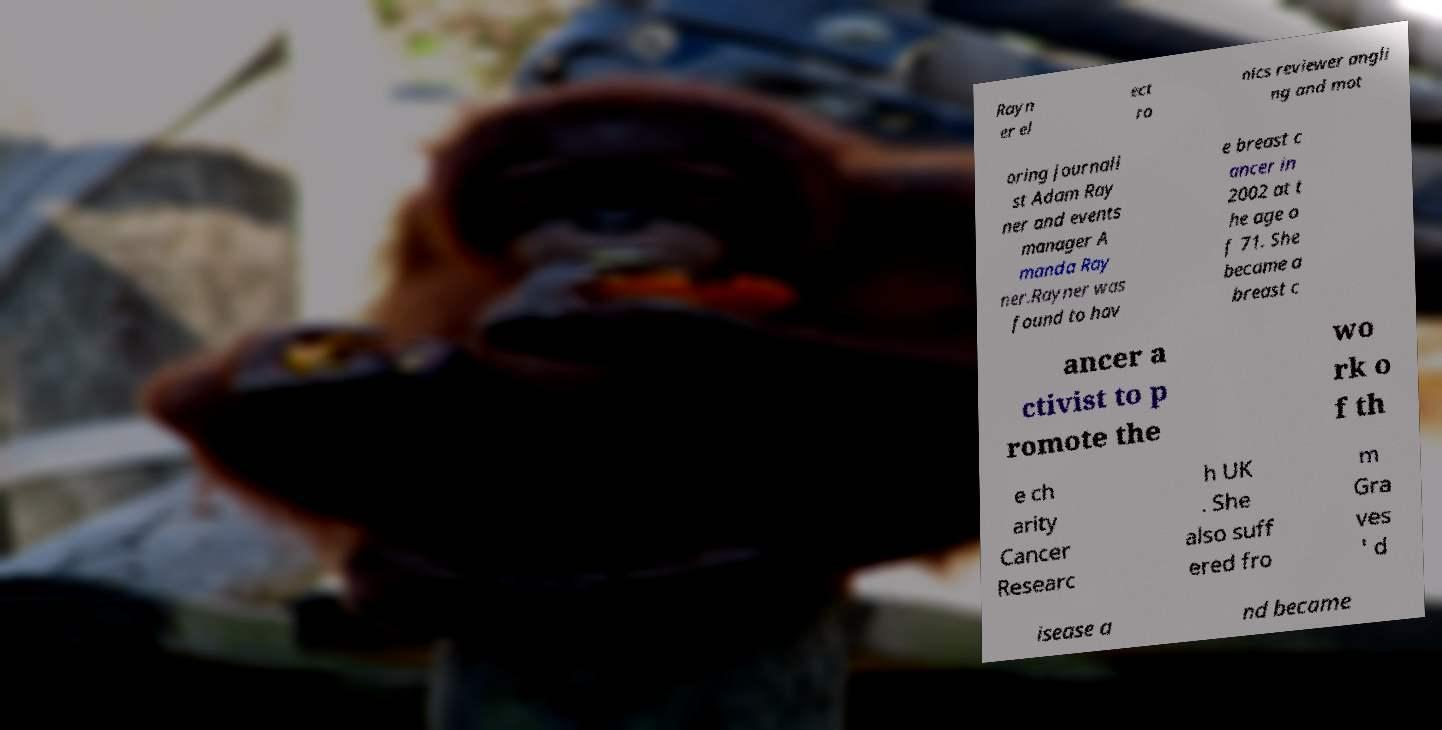Can you accurately transcribe the text from the provided image for me? Rayn er el ect ro nics reviewer angli ng and mot oring journali st Adam Ray ner and events manager A manda Ray ner.Rayner was found to hav e breast c ancer in 2002 at t he age o f 71. She became a breast c ancer a ctivist to p romote the wo rk o f th e ch arity Cancer Researc h UK . She also suff ered fro m Gra ves ' d isease a nd became 